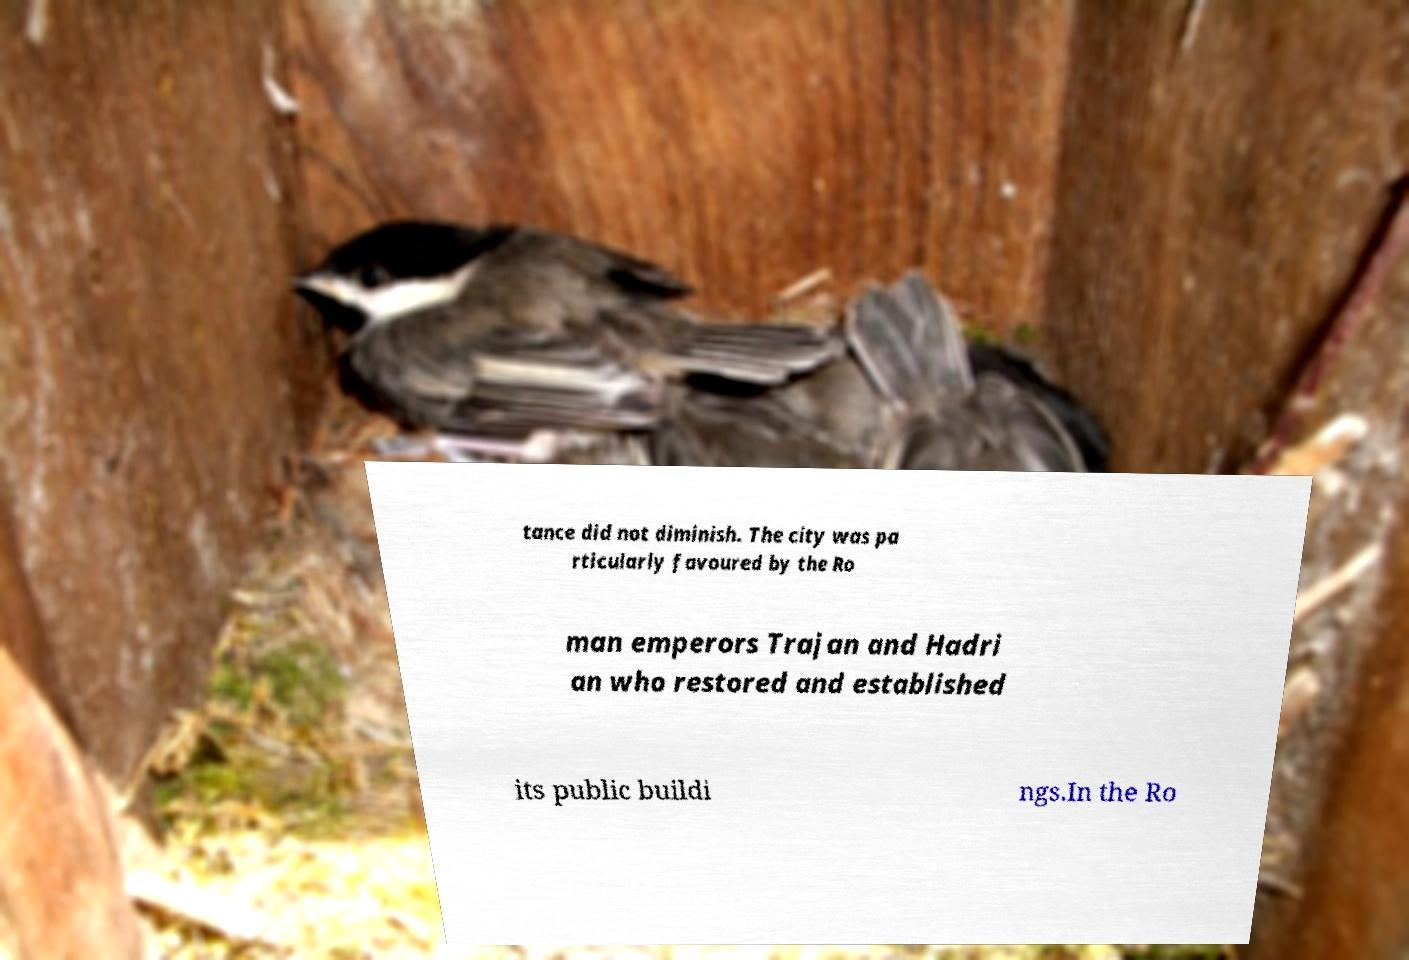Please identify and transcribe the text found in this image. tance did not diminish. The city was pa rticularly favoured by the Ro man emperors Trajan and Hadri an who restored and established its public buildi ngs.In the Ro 